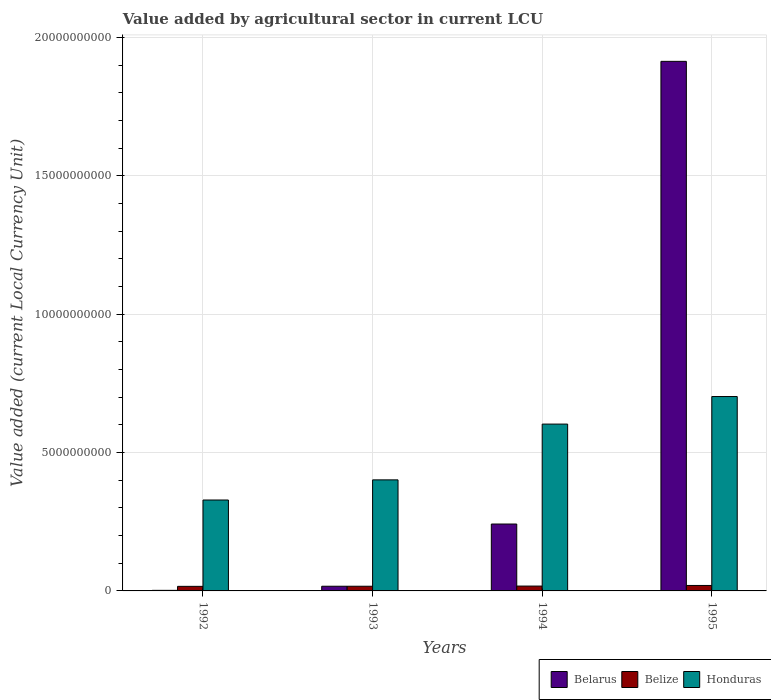How many different coloured bars are there?
Make the answer very short. 3. Are the number of bars per tick equal to the number of legend labels?
Your answer should be very brief. Yes. Are the number of bars on each tick of the X-axis equal?
Offer a terse response. Yes. How many bars are there on the 1st tick from the left?
Your response must be concise. 3. How many bars are there on the 4th tick from the right?
Offer a terse response. 3. What is the value added by agricultural sector in Belarus in 1992?
Make the answer very short. 2.07e+07. Across all years, what is the maximum value added by agricultural sector in Belarus?
Make the answer very short. 1.91e+1. Across all years, what is the minimum value added by agricultural sector in Honduras?
Offer a terse response. 3.29e+09. In which year was the value added by agricultural sector in Belarus maximum?
Provide a succinct answer. 1995. What is the total value added by agricultural sector in Belarus in the graph?
Make the answer very short. 2.17e+1. What is the difference between the value added by agricultural sector in Honduras in 1993 and that in 1995?
Give a very brief answer. -3.01e+09. What is the difference between the value added by agricultural sector in Belarus in 1992 and the value added by agricultural sector in Honduras in 1993?
Keep it short and to the point. -3.99e+09. What is the average value added by agricultural sector in Belize per year?
Your answer should be compact. 1.77e+08. In the year 1993, what is the difference between the value added by agricultural sector in Honduras and value added by agricultural sector in Belize?
Make the answer very short. 3.84e+09. In how many years, is the value added by agricultural sector in Belarus greater than 15000000000 LCU?
Offer a very short reply. 1. What is the ratio of the value added by agricultural sector in Belize in 1993 to that in 1995?
Give a very brief answer. 0.86. Is the value added by agricultural sector in Belize in 1993 less than that in 1995?
Your answer should be compact. Yes. What is the difference between the highest and the second highest value added by agricultural sector in Belize?
Your answer should be very brief. 2.25e+07. What is the difference between the highest and the lowest value added by agricultural sector in Belarus?
Offer a terse response. 1.91e+1. In how many years, is the value added by agricultural sector in Belarus greater than the average value added by agricultural sector in Belarus taken over all years?
Your answer should be very brief. 1. What does the 2nd bar from the left in 1993 represents?
Provide a succinct answer. Belize. What does the 2nd bar from the right in 1993 represents?
Make the answer very short. Belize. Does the graph contain any zero values?
Your answer should be compact. No. Does the graph contain grids?
Give a very brief answer. Yes. How many legend labels are there?
Provide a succinct answer. 3. How are the legend labels stacked?
Your response must be concise. Horizontal. What is the title of the graph?
Ensure brevity in your answer.  Value added by agricultural sector in current LCU. What is the label or title of the Y-axis?
Offer a very short reply. Value added (current Local Currency Unit). What is the Value added (current Local Currency Unit) of Belarus in 1992?
Keep it short and to the point. 2.07e+07. What is the Value added (current Local Currency Unit) in Belize in 1992?
Keep it short and to the point. 1.65e+08. What is the Value added (current Local Currency Unit) of Honduras in 1992?
Offer a very short reply. 3.29e+09. What is the Value added (current Local Currency Unit) in Belarus in 1993?
Provide a succinct answer. 1.69e+08. What is the Value added (current Local Currency Unit) in Belize in 1993?
Give a very brief answer. 1.69e+08. What is the Value added (current Local Currency Unit) of Honduras in 1993?
Give a very brief answer. 4.01e+09. What is the Value added (current Local Currency Unit) of Belarus in 1994?
Provide a succinct answer. 2.42e+09. What is the Value added (current Local Currency Unit) of Belize in 1994?
Offer a very short reply. 1.75e+08. What is the Value added (current Local Currency Unit) in Honduras in 1994?
Your answer should be very brief. 6.03e+09. What is the Value added (current Local Currency Unit) in Belarus in 1995?
Your answer should be compact. 1.91e+1. What is the Value added (current Local Currency Unit) in Belize in 1995?
Your answer should be compact. 1.98e+08. What is the Value added (current Local Currency Unit) in Honduras in 1995?
Ensure brevity in your answer.  7.03e+09. Across all years, what is the maximum Value added (current Local Currency Unit) of Belarus?
Your answer should be compact. 1.91e+1. Across all years, what is the maximum Value added (current Local Currency Unit) of Belize?
Your response must be concise. 1.98e+08. Across all years, what is the maximum Value added (current Local Currency Unit) of Honduras?
Your answer should be very brief. 7.03e+09. Across all years, what is the minimum Value added (current Local Currency Unit) in Belarus?
Provide a succinct answer. 2.07e+07. Across all years, what is the minimum Value added (current Local Currency Unit) in Belize?
Your answer should be very brief. 1.65e+08. Across all years, what is the minimum Value added (current Local Currency Unit) in Honduras?
Keep it short and to the point. 3.29e+09. What is the total Value added (current Local Currency Unit) of Belarus in the graph?
Ensure brevity in your answer.  2.17e+1. What is the total Value added (current Local Currency Unit) of Belize in the graph?
Your answer should be very brief. 7.07e+08. What is the total Value added (current Local Currency Unit) of Honduras in the graph?
Your response must be concise. 2.04e+1. What is the difference between the Value added (current Local Currency Unit) in Belarus in 1992 and that in 1993?
Give a very brief answer. -1.48e+08. What is the difference between the Value added (current Local Currency Unit) of Belize in 1992 and that in 1993?
Your response must be concise. -3.79e+06. What is the difference between the Value added (current Local Currency Unit) of Honduras in 1992 and that in 1993?
Give a very brief answer. -7.28e+08. What is the difference between the Value added (current Local Currency Unit) of Belarus in 1992 and that in 1994?
Offer a very short reply. -2.40e+09. What is the difference between the Value added (current Local Currency Unit) in Belize in 1992 and that in 1994?
Your response must be concise. -9.67e+06. What is the difference between the Value added (current Local Currency Unit) of Honduras in 1992 and that in 1994?
Offer a very short reply. -2.74e+09. What is the difference between the Value added (current Local Currency Unit) of Belarus in 1992 and that in 1995?
Keep it short and to the point. -1.91e+1. What is the difference between the Value added (current Local Currency Unit) in Belize in 1992 and that in 1995?
Offer a very short reply. -3.22e+07. What is the difference between the Value added (current Local Currency Unit) in Honduras in 1992 and that in 1995?
Ensure brevity in your answer.  -3.74e+09. What is the difference between the Value added (current Local Currency Unit) of Belarus in 1993 and that in 1994?
Make the answer very short. -2.25e+09. What is the difference between the Value added (current Local Currency Unit) in Belize in 1993 and that in 1994?
Provide a succinct answer. -5.88e+06. What is the difference between the Value added (current Local Currency Unit) of Honduras in 1993 and that in 1994?
Your answer should be compact. -2.02e+09. What is the difference between the Value added (current Local Currency Unit) in Belarus in 1993 and that in 1995?
Ensure brevity in your answer.  -1.90e+1. What is the difference between the Value added (current Local Currency Unit) of Belize in 1993 and that in 1995?
Keep it short and to the point. -2.84e+07. What is the difference between the Value added (current Local Currency Unit) in Honduras in 1993 and that in 1995?
Give a very brief answer. -3.01e+09. What is the difference between the Value added (current Local Currency Unit) in Belarus in 1994 and that in 1995?
Offer a very short reply. -1.67e+1. What is the difference between the Value added (current Local Currency Unit) of Belize in 1994 and that in 1995?
Offer a terse response. -2.25e+07. What is the difference between the Value added (current Local Currency Unit) of Honduras in 1994 and that in 1995?
Offer a very short reply. -9.96e+08. What is the difference between the Value added (current Local Currency Unit) in Belarus in 1992 and the Value added (current Local Currency Unit) in Belize in 1993?
Ensure brevity in your answer.  -1.48e+08. What is the difference between the Value added (current Local Currency Unit) in Belarus in 1992 and the Value added (current Local Currency Unit) in Honduras in 1993?
Your answer should be very brief. -3.99e+09. What is the difference between the Value added (current Local Currency Unit) of Belize in 1992 and the Value added (current Local Currency Unit) of Honduras in 1993?
Offer a terse response. -3.85e+09. What is the difference between the Value added (current Local Currency Unit) in Belarus in 1992 and the Value added (current Local Currency Unit) in Belize in 1994?
Ensure brevity in your answer.  -1.54e+08. What is the difference between the Value added (current Local Currency Unit) of Belarus in 1992 and the Value added (current Local Currency Unit) of Honduras in 1994?
Your answer should be compact. -6.01e+09. What is the difference between the Value added (current Local Currency Unit) in Belize in 1992 and the Value added (current Local Currency Unit) in Honduras in 1994?
Your answer should be compact. -5.86e+09. What is the difference between the Value added (current Local Currency Unit) in Belarus in 1992 and the Value added (current Local Currency Unit) in Belize in 1995?
Your answer should be very brief. -1.77e+08. What is the difference between the Value added (current Local Currency Unit) in Belarus in 1992 and the Value added (current Local Currency Unit) in Honduras in 1995?
Ensure brevity in your answer.  -7.01e+09. What is the difference between the Value added (current Local Currency Unit) in Belize in 1992 and the Value added (current Local Currency Unit) in Honduras in 1995?
Your answer should be very brief. -6.86e+09. What is the difference between the Value added (current Local Currency Unit) of Belarus in 1993 and the Value added (current Local Currency Unit) of Belize in 1994?
Offer a very short reply. -6.07e+06. What is the difference between the Value added (current Local Currency Unit) of Belarus in 1993 and the Value added (current Local Currency Unit) of Honduras in 1994?
Keep it short and to the point. -5.86e+09. What is the difference between the Value added (current Local Currency Unit) in Belize in 1993 and the Value added (current Local Currency Unit) in Honduras in 1994?
Your response must be concise. -5.86e+09. What is the difference between the Value added (current Local Currency Unit) in Belarus in 1993 and the Value added (current Local Currency Unit) in Belize in 1995?
Your answer should be very brief. -2.86e+07. What is the difference between the Value added (current Local Currency Unit) in Belarus in 1993 and the Value added (current Local Currency Unit) in Honduras in 1995?
Give a very brief answer. -6.86e+09. What is the difference between the Value added (current Local Currency Unit) of Belize in 1993 and the Value added (current Local Currency Unit) of Honduras in 1995?
Keep it short and to the point. -6.86e+09. What is the difference between the Value added (current Local Currency Unit) of Belarus in 1994 and the Value added (current Local Currency Unit) of Belize in 1995?
Keep it short and to the point. 2.22e+09. What is the difference between the Value added (current Local Currency Unit) in Belarus in 1994 and the Value added (current Local Currency Unit) in Honduras in 1995?
Offer a very short reply. -4.61e+09. What is the difference between the Value added (current Local Currency Unit) of Belize in 1994 and the Value added (current Local Currency Unit) of Honduras in 1995?
Make the answer very short. -6.85e+09. What is the average Value added (current Local Currency Unit) of Belarus per year?
Your response must be concise. 5.44e+09. What is the average Value added (current Local Currency Unit) of Belize per year?
Make the answer very short. 1.77e+08. What is the average Value added (current Local Currency Unit) of Honduras per year?
Provide a succinct answer. 5.09e+09. In the year 1992, what is the difference between the Value added (current Local Currency Unit) of Belarus and Value added (current Local Currency Unit) of Belize?
Offer a very short reply. -1.45e+08. In the year 1992, what is the difference between the Value added (current Local Currency Unit) of Belarus and Value added (current Local Currency Unit) of Honduras?
Offer a very short reply. -3.27e+09. In the year 1992, what is the difference between the Value added (current Local Currency Unit) of Belize and Value added (current Local Currency Unit) of Honduras?
Make the answer very short. -3.12e+09. In the year 1993, what is the difference between the Value added (current Local Currency Unit) of Belarus and Value added (current Local Currency Unit) of Belize?
Your answer should be compact. -1.93e+05. In the year 1993, what is the difference between the Value added (current Local Currency Unit) of Belarus and Value added (current Local Currency Unit) of Honduras?
Provide a succinct answer. -3.84e+09. In the year 1993, what is the difference between the Value added (current Local Currency Unit) in Belize and Value added (current Local Currency Unit) in Honduras?
Offer a terse response. -3.84e+09. In the year 1994, what is the difference between the Value added (current Local Currency Unit) of Belarus and Value added (current Local Currency Unit) of Belize?
Offer a very short reply. 2.24e+09. In the year 1994, what is the difference between the Value added (current Local Currency Unit) of Belarus and Value added (current Local Currency Unit) of Honduras?
Provide a short and direct response. -3.61e+09. In the year 1994, what is the difference between the Value added (current Local Currency Unit) of Belize and Value added (current Local Currency Unit) of Honduras?
Your response must be concise. -5.85e+09. In the year 1995, what is the difference between the Value added (current Local Currency Unit) in Belarus and Value added (current Local Currency Unit) in Belize?
Your response must be concise. 1.89e+1. In the year 1995, what is the difference between the Value added (current Local Currency Unit) in Belarus and Value added (current Local Currency Unit) in Honduras?
Provide a succinct answer. 1.21e+1. In the year 1995, what is the difference between the Value added (current Local Currency Unit) in Belize and Value added (current Local Currency Unit) in Honduras?
Your response must be concise. -6.83e+09. What is the ratio of the Value added (current Local Currency Unit) in Belarus in 1992 to that in 1993?
Ensure brevity in your answer.  0.12. What is the ratio of the Value added (current Local Currency Unit) of Belize in 1992 to that in 1993?
Make the answer very short. 0.98. What is the ratio of the Value added (current Local Currency Unit) of Honduras in 1992 to that in 1993?
Offer a terse response. 0.82. What is the ratio of the Value added (current Local Currency Unit) in Belarus in 1992 to that in 1994?
Ensure brevity in your answer.  0.01. What is the ratio of the Value added (current Local Currency Unit) in Belize in 1992 to that in 1994?
Provide a short and direct response. 0.94. What is the ratio of the Value added (current Local Currency Unit) in Honduras in 1992 to that in 1994?
Provide a succinct answer. 0.54. What is the ratio of the Value added (current Local Currency Unit) in Belarus in 1992 to that in 1995?
Ensure brevity in your answer.  0. What is the ratio of the Value added (current Local Currency Unit) in Belize in 1992 to that in 1995?
Offer a terse response. 0.84. What is the ratio of the Value added (current Local Currency Unit) in Honduras in 1992 to that in 1995?
Ensure brevity in your answer.  0.47. What is the ratio of the Value added (current Local Currency Unit) in Belarus in 1993 to that in 1994?
Provide a succinct answer. 0.07. What is the ratio of the Value added (current Local Currency Unit) of Belize in 1993 to that in 1994?
Your answer should be very brief. 0.97. What is the ratio of the Value added (current Local Currency Unit) in Honduras in 1993 to that in 1994?
Provide a short and direct response. 0.67. What is the ratio of the Value added (current Local Currency Unit) in Belarus in 1993 to that in 1995?
Give a very brief answer. 0.01. What is the ratio of the Value added (current Local Currency Unit) of Belize in 1993 to that in 1995?
Your answer should be very brief. 0.86. What is the ratio of the Value added (current Local Currency Unit) in Honduras in 1993 to that in 1995?
Your answer should be very brief. 0.57. What is the ratio of the Value added (current Local Currency Unit) of Belarus in 1994 to that in 1995?
Your response must be concise. 0.13. What is the ratio of the Value added (current Local Currency Unit) in Belize in 1994 to that in 1995?
Provide a succinct answer. 0.89. What is the ratio of the Value added (current Local Currency Unit) in Honduras in 1994 to that in 1995?
Your answer should be very brief. 0.86. What is the difference between the highest and the second highest Value added (current Local Currency Unit) of Belarus?
Your answer should be compact. 1.67e+1. What is the difference between the highest and the second highest Value added (current Local Currency Unit) of Belize?
Your answer should be compact. 2.25e+07. What is the difference between the highest and the second highest Value added (current Local Currency Unit) in Honduras?
Give a very brief answer. 9.96e+08. What is the difference between the highest and the lowest Value added (current Local Currency Unit) of Belarus?
Offer a very short reply. 1.91e+1. What is the difference between the highest and the lowest Value added (current Local Currency Unit) in Belize?
Provide a succinct answer. 3.22e+07. What is the difference between the highest and the lowest Value added (current Local Currency Unit) in Honduras?
Keep it short and to the point. 3.74e+09. 